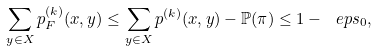Convert formula to latex. <formula><loc_0><loc_0><loc_500><loc_500>\sum _ { y \in X } p ^ { ( k ) } _ { F } ( x , y ) \leq \sum _ { y \in X } p ^ { ( k ) } ( x , y ) - \mathbb { P } ( \pi ) \leq 1 - \ e p s _ { 0 } ,</formula> 